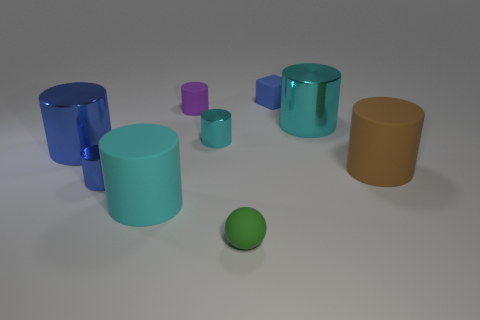How many objects are there in total? I can count a total of seven objects within the image. Are they all the same color? No, the objects feature a variety of colors including shades of blue, green, purple, and orange. 